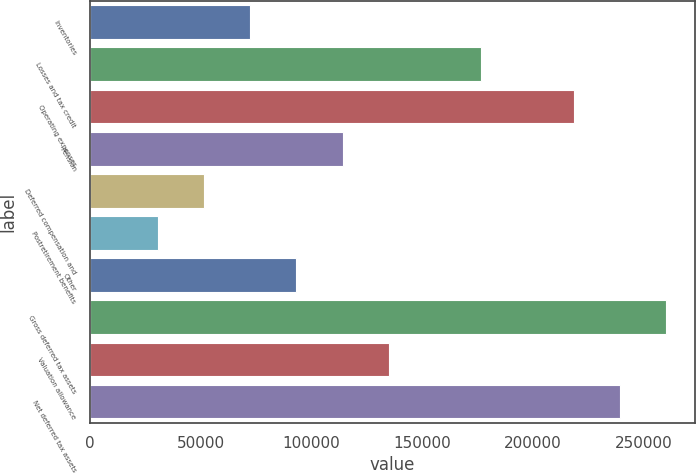<chart> <loc_0><loc_0><loc_500><loc_500><bar_chart><fcel>Inventories<fcel>Losses and tax credit<fcel>Operating expenses<fcel>Pension<fcel>Deferred compensation and<fcel>Postretirement benefits<fcel>Other<fcel>Gross deferred tax assets<fcel>Valuation allowance<fcel>Net deferred tax assets<nl><fcel>72292.3<fcel>176683<fcel>218439<fcel>114048<fcel>51414.2<fcel>30536.1<fcel>93170.4<fcel>260195<fcel>134927<fcel>239317<nl></chart> 